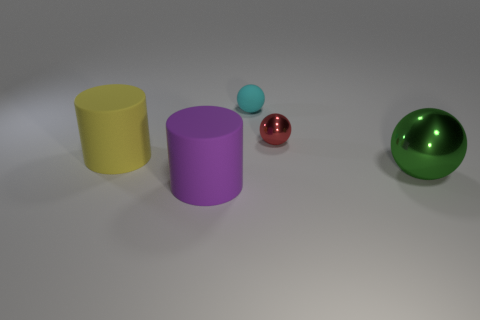Subtract all large green metallic balls. How many balls are left? 2 Subtract all red balls. How many balls are left? 2 Subtract all cylinders. How many objects are left? 3 Add 3 big shiny blocks. How many objects exist? 8 Add 5 large red balls. How many large red balls exist? 5 Subtract 1 purple cylinders. How many objects are left? 4 Subtract 1 cylinders. How many cylinders are left? 1 Subtract all red balls. Subtract all yellow cylinders. How many balls are left? 2 Subtract all large brown metal spheres. Subtract all big purple cylinders. How many objects are left? 4 Add 1 yellow rubber objects. How many yellow rubber objects are left? 2 